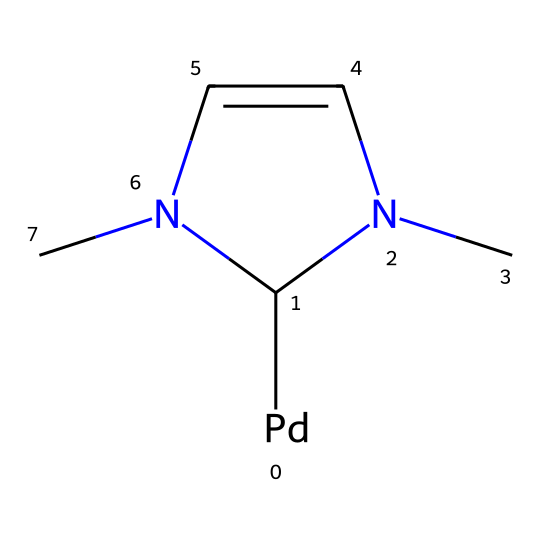What is the metal center in this carbene complex? The structure includes a palladium atom denoted by [Pd] in the SMILES notation, which indicates that palladium is the metal center in this carbene complex.
Answer: palladium How many nitrogen atoms are present in this structure? Analyzing the structure, we see two nitrogen atoms labeled 'N' within the ring. Therefore, the total count of nitrogen atoms is two.
Answer: two What type of carbene is represented in this structure? The carbene in this complex is a stabilized carbene due to the presence of surrounding atoms (the nitrogen and the metal), indicating that it is a stable form.
Answer: stabilized How many carbon atoms are present in the cyclic part of the structure? The cyclic portion of the compound has a total of four carbon atoms, which can be counted from the ring structure visible in the SMILES.
Answer: four What is the significance of the nitrogen atoms in the carbene complex? The nitrogen atoms help stabilize the carbanion center due to their ability to donate electrons, which is a key feature in carbene complexes in organometallic chemistry.
Answer: stabilizing Is the depicted carbene complex suitable for green chemistry applications? Yes, this complex can facilitate reactions under milder conditions, reducing the amount of waste and the use of hazardous materials, which is a principle of green chemistry.
Answer: yes 